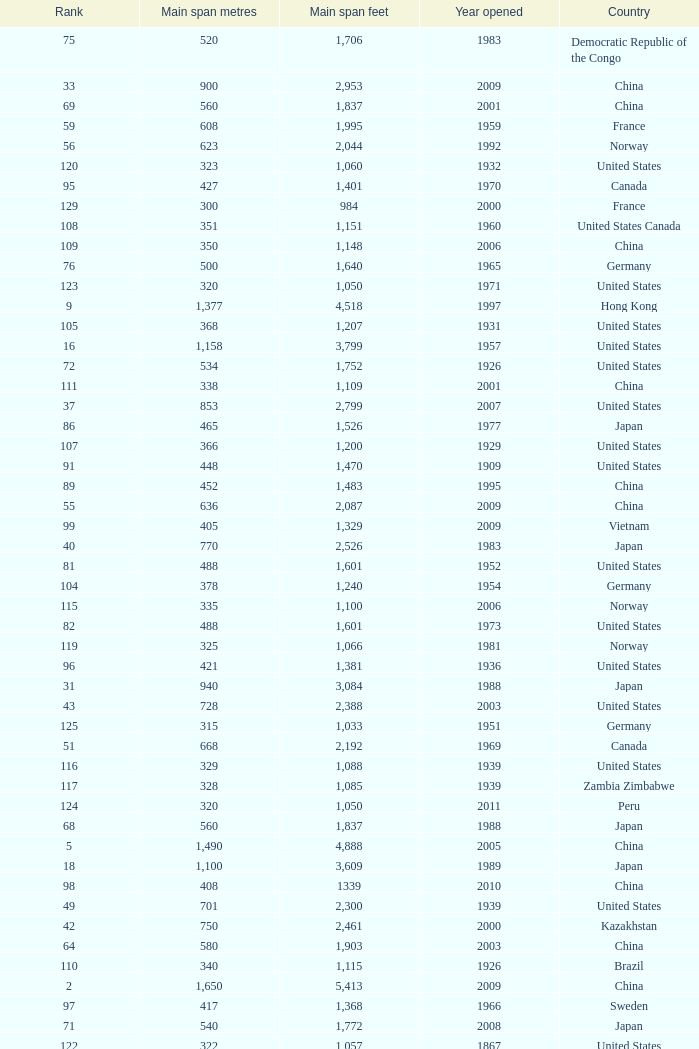What is the oldest year with a main span feet of 1,640 in South Korea? 2002.0. 